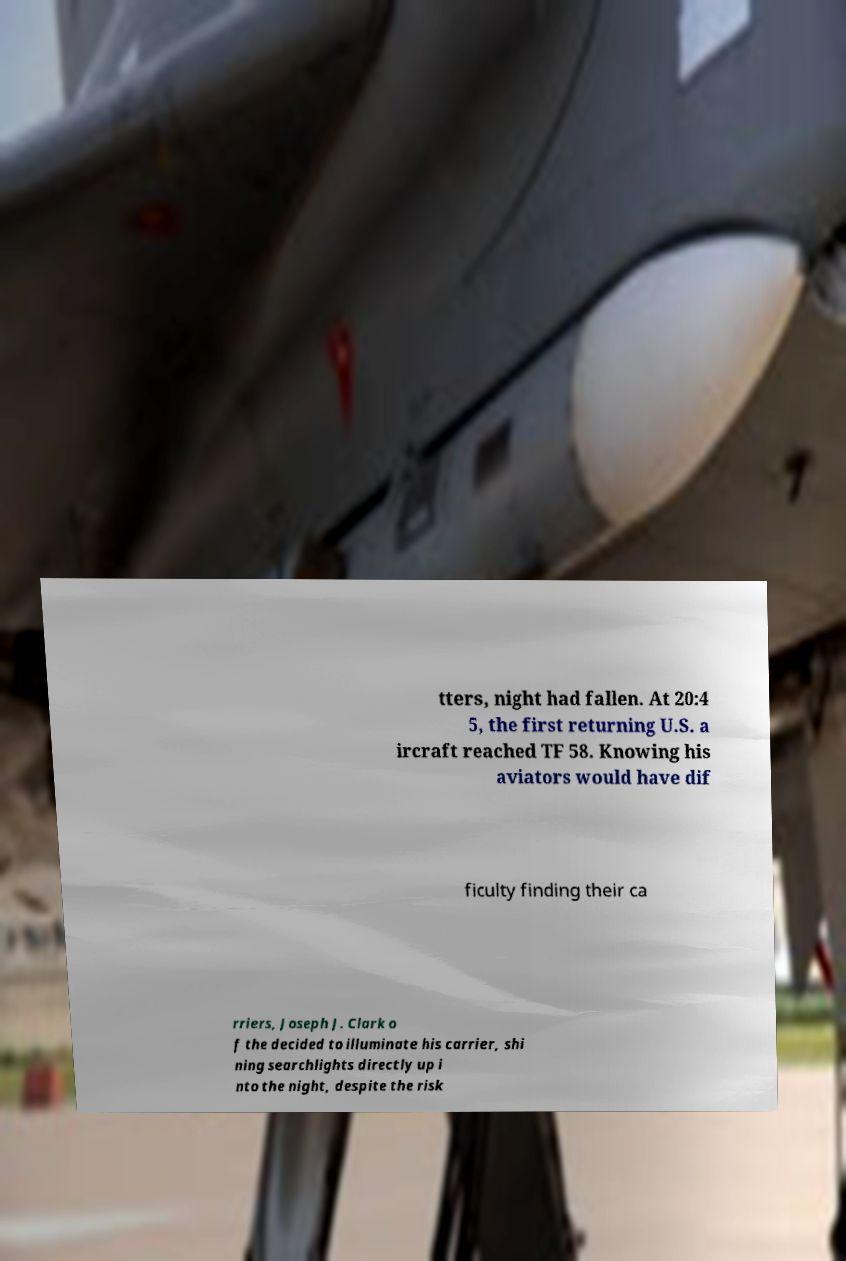Can you accurately transcribe the text from the provided image for me? tters, night had fallen. At 20:4 5, the first returning U.S. a ircraft reached TF 58. Knowing his aviators would have dif ficulty finding their ca rriers, Joseph J. Clark o f the decided to illuminate his carrier, shi ning searchlights directly up i nto the night, despite the risk 